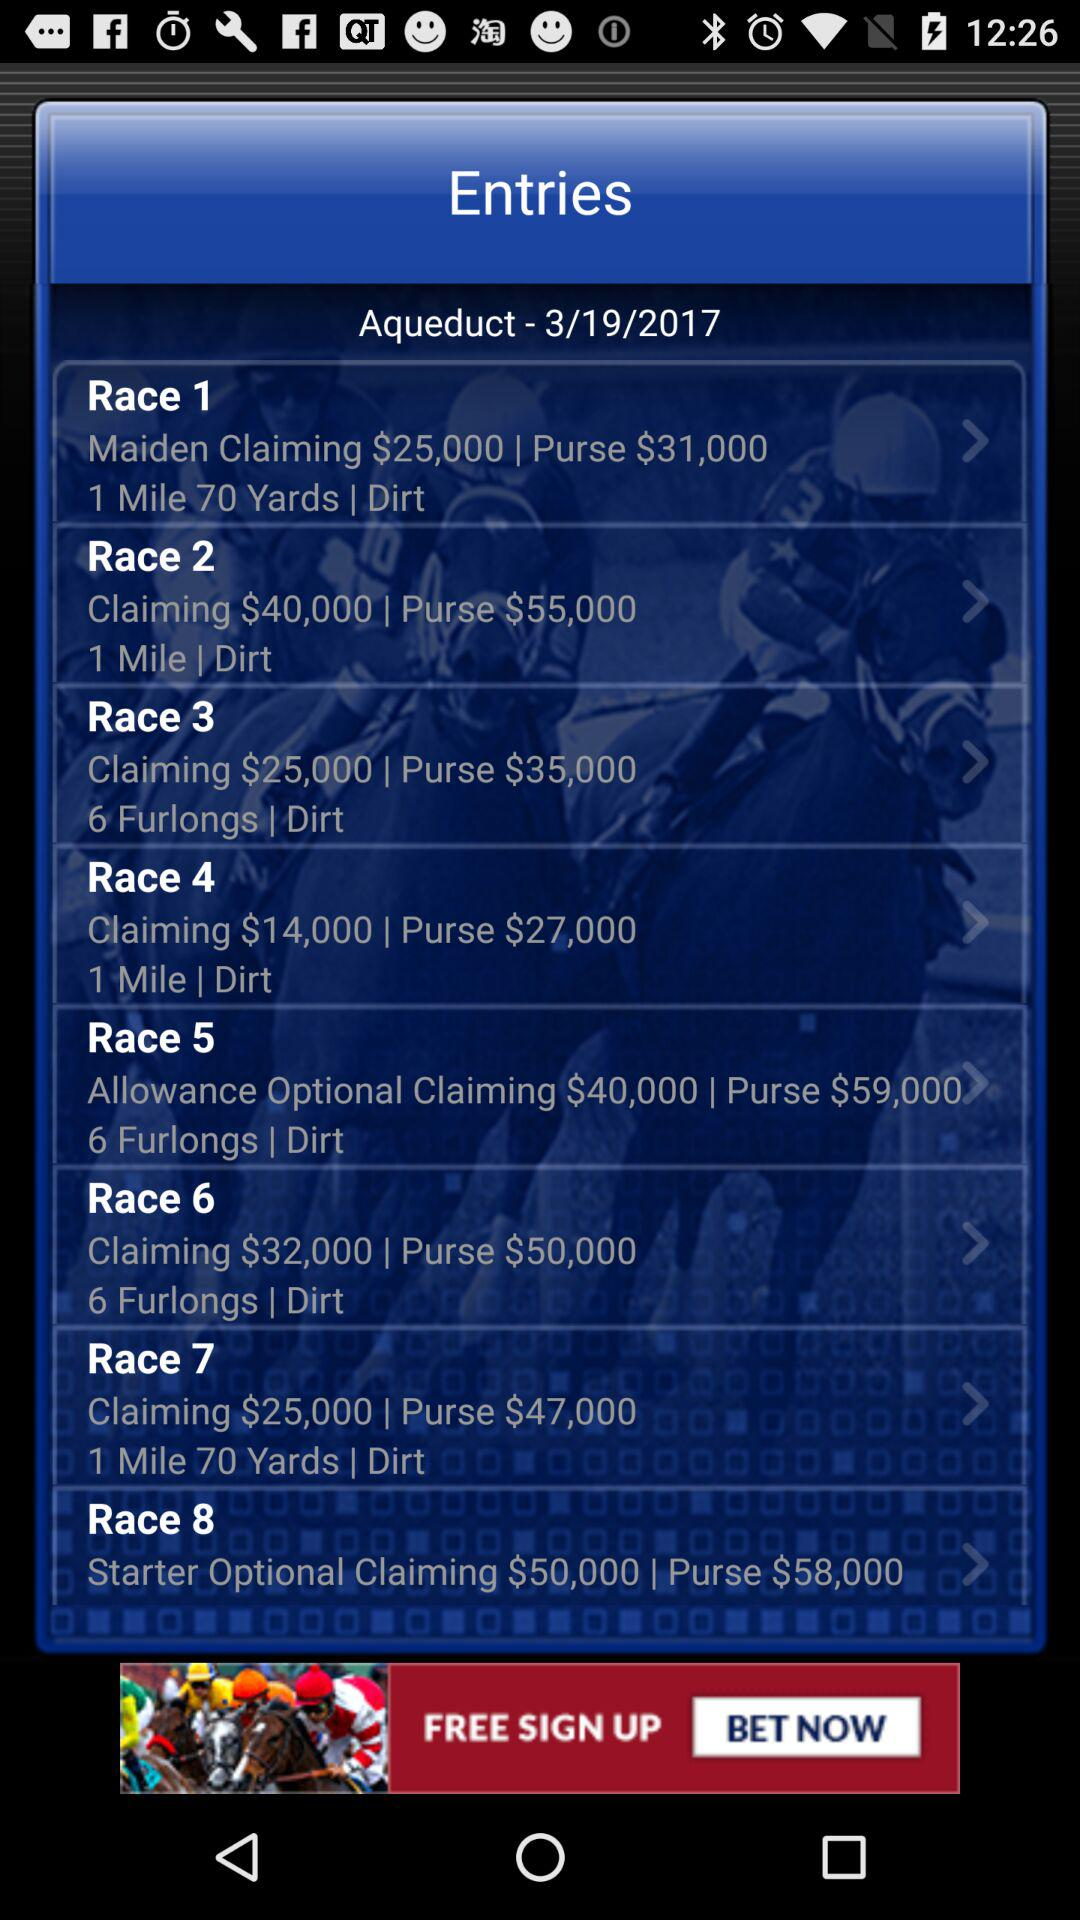How much does it cost to enter Race 6?
When the provided information is insufficient, respond with <no answer>. <no answer> 